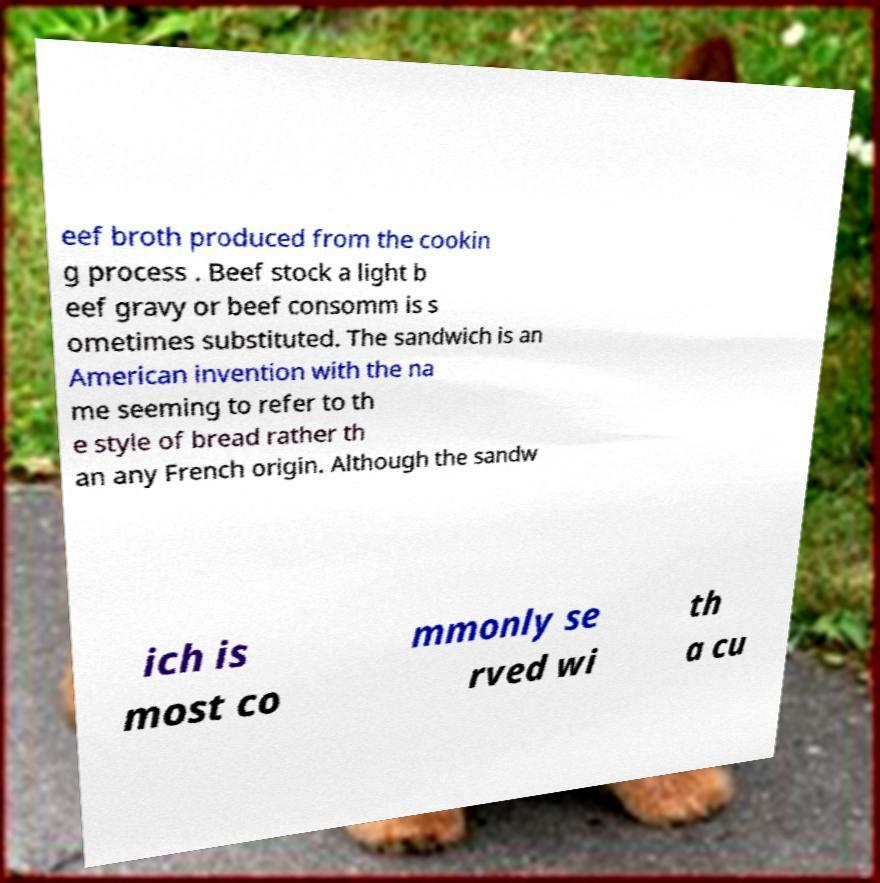For documentation purposes, I need the text within this image transcribed. Could you provide that? eef broth produced from the cookin g process . Beef stock a light b eef gravy or beef consomm is s ometimes substituted. The sandwich is an American invention with the na me seeming to refer to th e style of bread rather th an any French origin. Although the sandw ich is most co mmonly se rved wi th a cu 